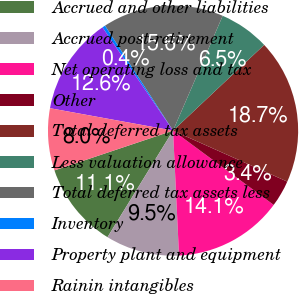Convert chart to OTSL. <chart><loc_0><loc_0><loc_500><loc_500><pie_chart><fcel>Accrued and other liabilities<fcel>Accrued post-retirement<fcel>Net operating loss and tax<fcel>Other<fcel>Total deferred tax assets<fcel>Less valuation allowance<fcel>Total deferred tax assets less<fcel>Inventory<fcel>Property plant and equipment<fcel>Rainin intangibles<nl><fcel>11.07%<fcel>9.54%<fcel>14.12%<fcel>3.44%<fcel>18.7%<fcel>6.49%<fcel>15.65%<fcel>0.39%<fcel>12.59%<fcel>8.02%<nl></chart> 